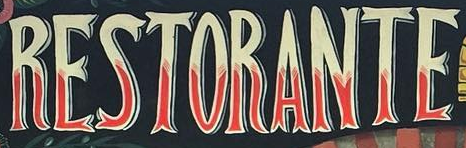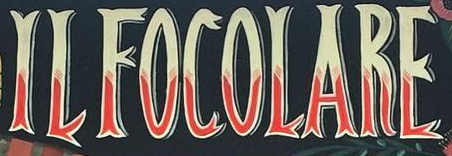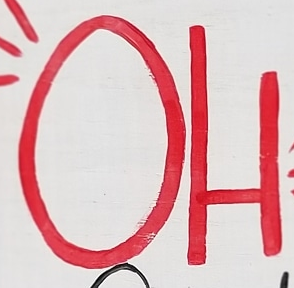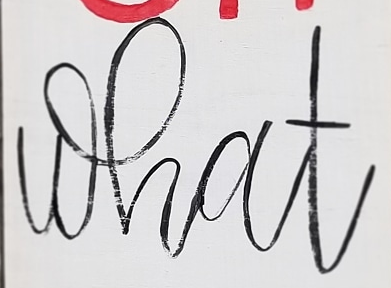What words are shown in these images in order, separated by a semicolon? RESTORANTE; ILFOCOLARE; OH; what 